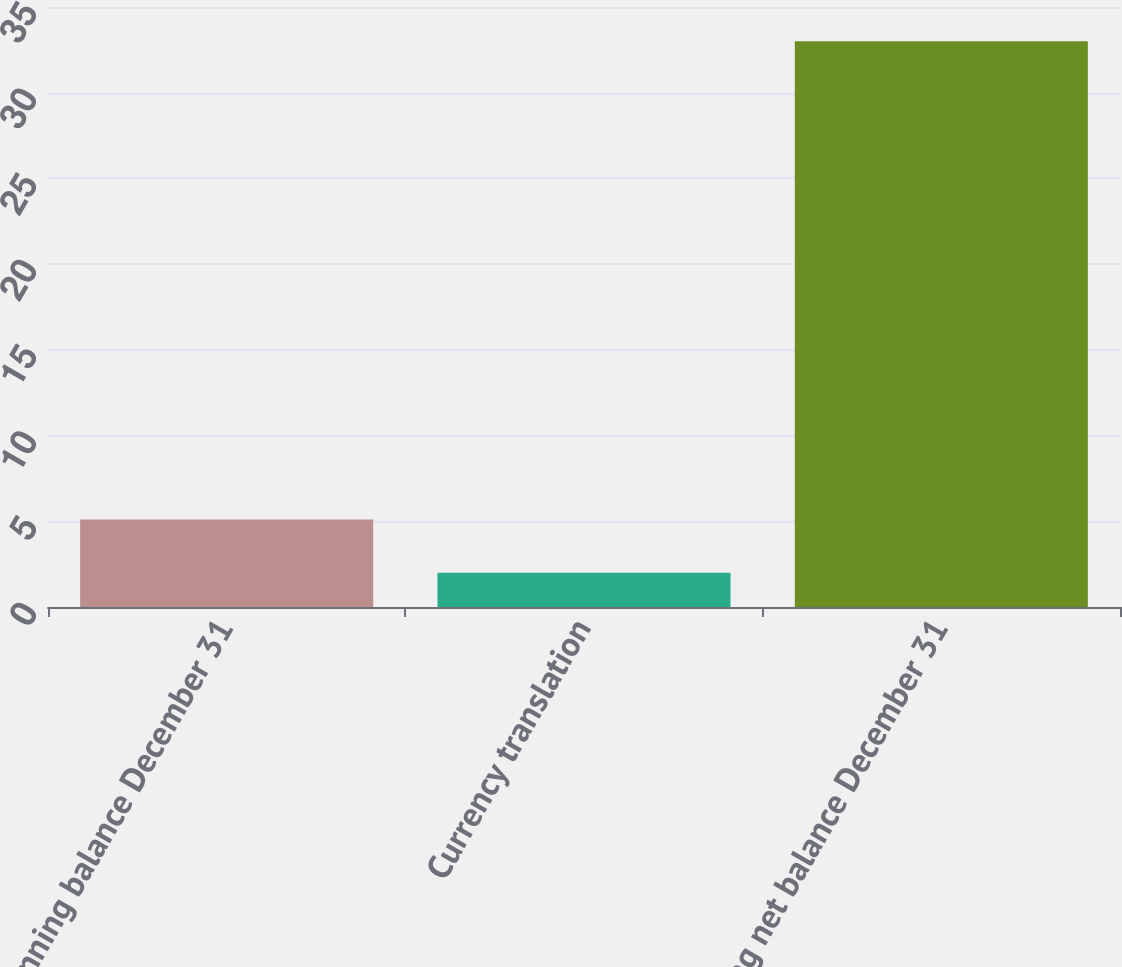<chart> <loc_0><loc_0><loc_500><loc_500><bar_chart><fcel>Beginning balance December 31<fcel>Currency translation<fcel>Ending net balance December 31<nl><fcel>5.1<fcel>2<fcel>33<nl></chart> 